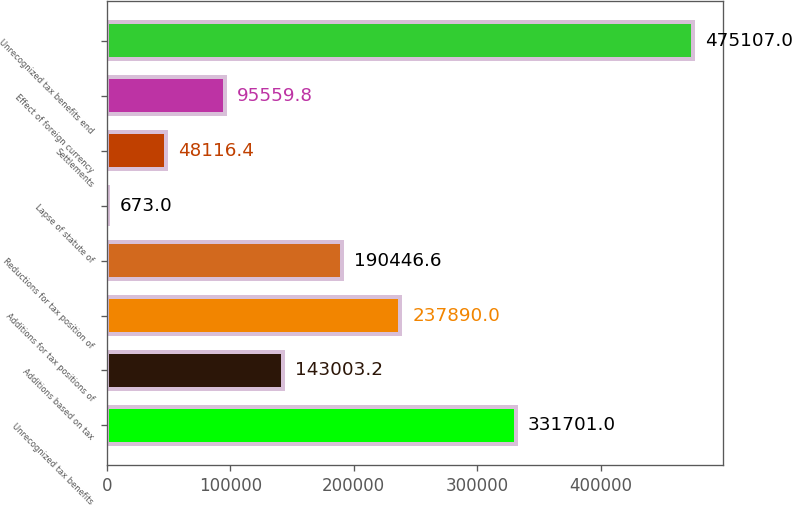Convert chart. <chart><loc_0><loc_0><loc_500><loc_500><bar_chart><fcel>Unrecognized tax benefits<fcel>Additions based on tax<fcel>Additions for tax positions of<fcel>Reductions for tax position of<fcel>Lapse of statute of<fcel>Settlements<fcel>Effect of foreign currency<fcel>Unrecognized tax benefits end<nl><fcel>331701<fcel>143003<fcel>237890<fcel>190447<fcel>673<fcel>48116.4<fcel>95559.8<fcel>475107<nl></chart> 